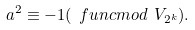Convert formula to latex. <formula><loc_0><loc_0><loc_500><loc_500>a ^ { 2 } \equiv - 1 ( \ f u n c { m o d } \text { } V _ { 2 ^ { k } } ) .</formula> 